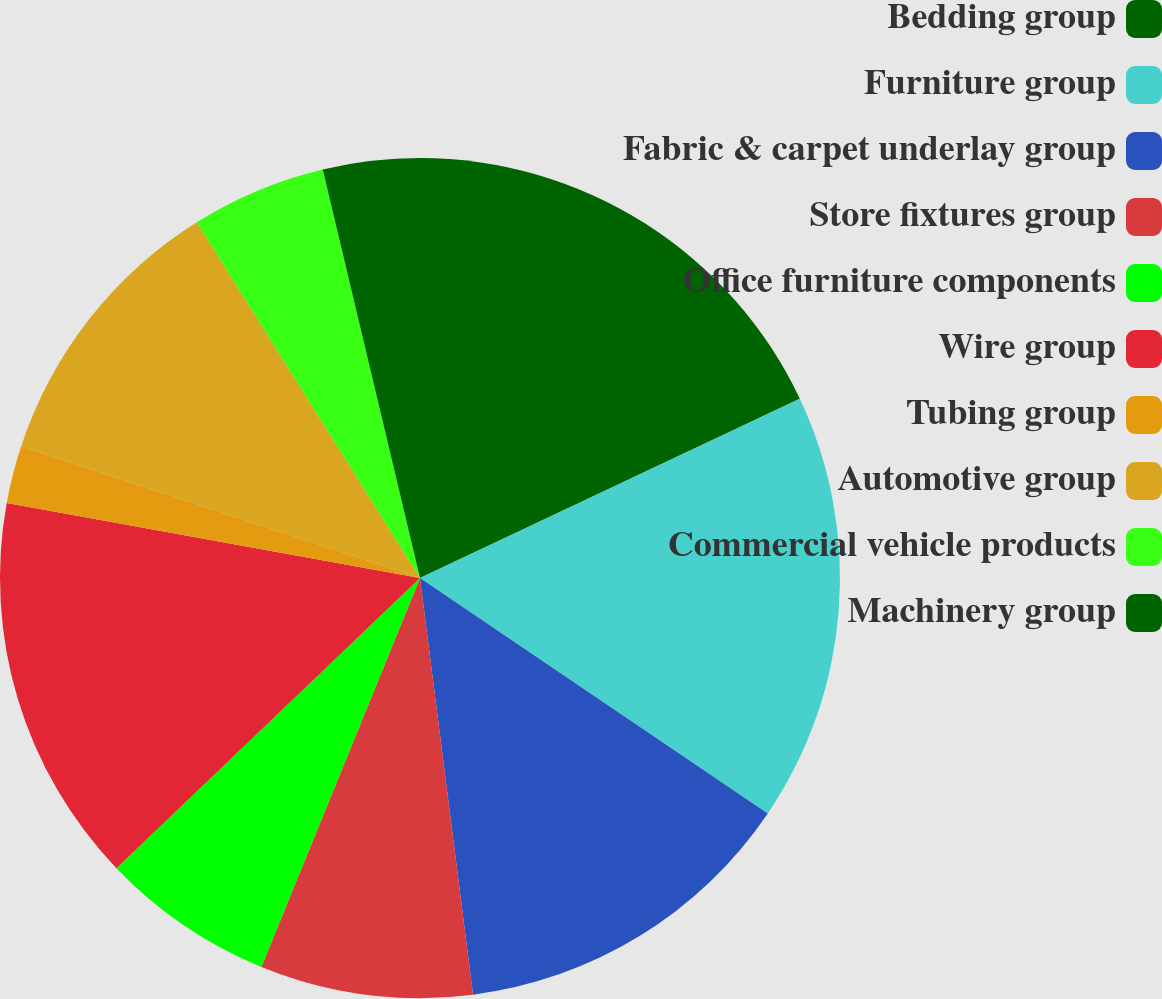<chart> <loc_0><loc_0><loc_500><loc_500><pie_chart><fcel>Bedding group<fcel>Furniture group<fcel>Fabric & carpet underlay group<fcel>Store fixtures group<fcel>Office furniture components<fcel>Wire group<fcel>Tubing group<fcel>Automotive group<fcel>Commercial vehicle products<fcel>Machinery group<nl><fcel>17.98%<fcel>16.49%<fcel>13.51%<fcel>8.18%<fcel>6.69%<fcel>15.0%<fcel>2.23%<fcel>10.99%<fcel>5.2%<fcel>3.72%<nl></chart> 